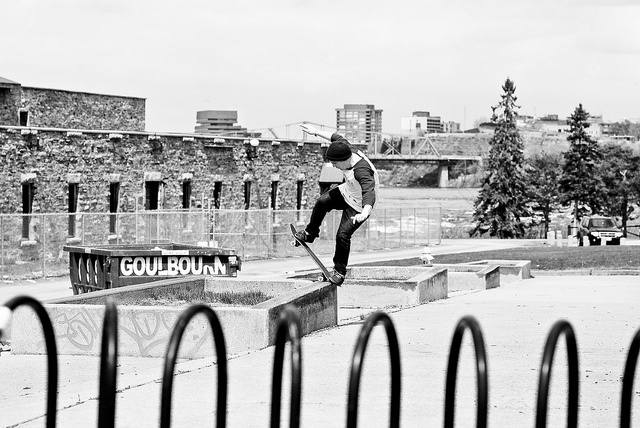Describe the objects in this image and their specific colors. I can see people in white, black, gray, lightgray, and darkgray tones, truck in white, black, darkgray, lightgray, and gray tones, skateboard in white, gray, darkgray, lightgray, and black tones, and fire hydrant in white, darkgray, gray, and black tones in this image. 